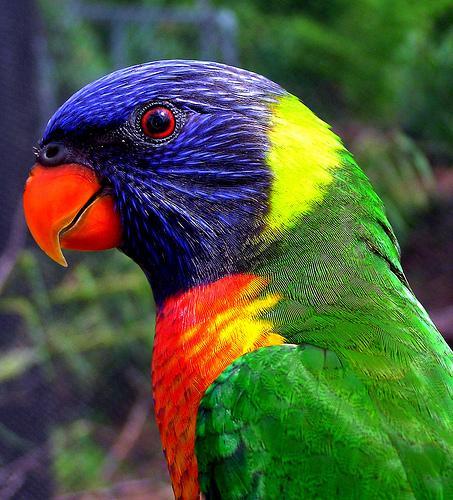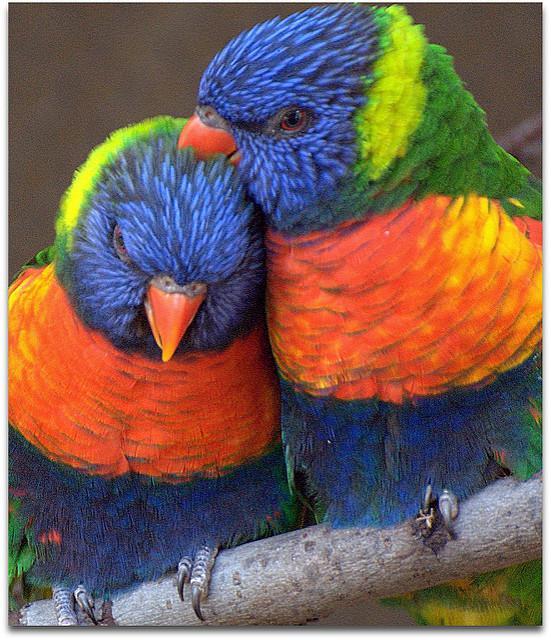The first image is the image on the left, the second image is the image on the right. For the images shown, is this caption "Four colorful birds are perched outside." true? Answer yes or no. No. The first image is the image on the left, the second image is the image on the right. Considering the images on both sides, is "Exactly four parrots are shown, one pair of similar coloring in each image, with one pair in or near vegetation." valid? Answer yes or no. No. 